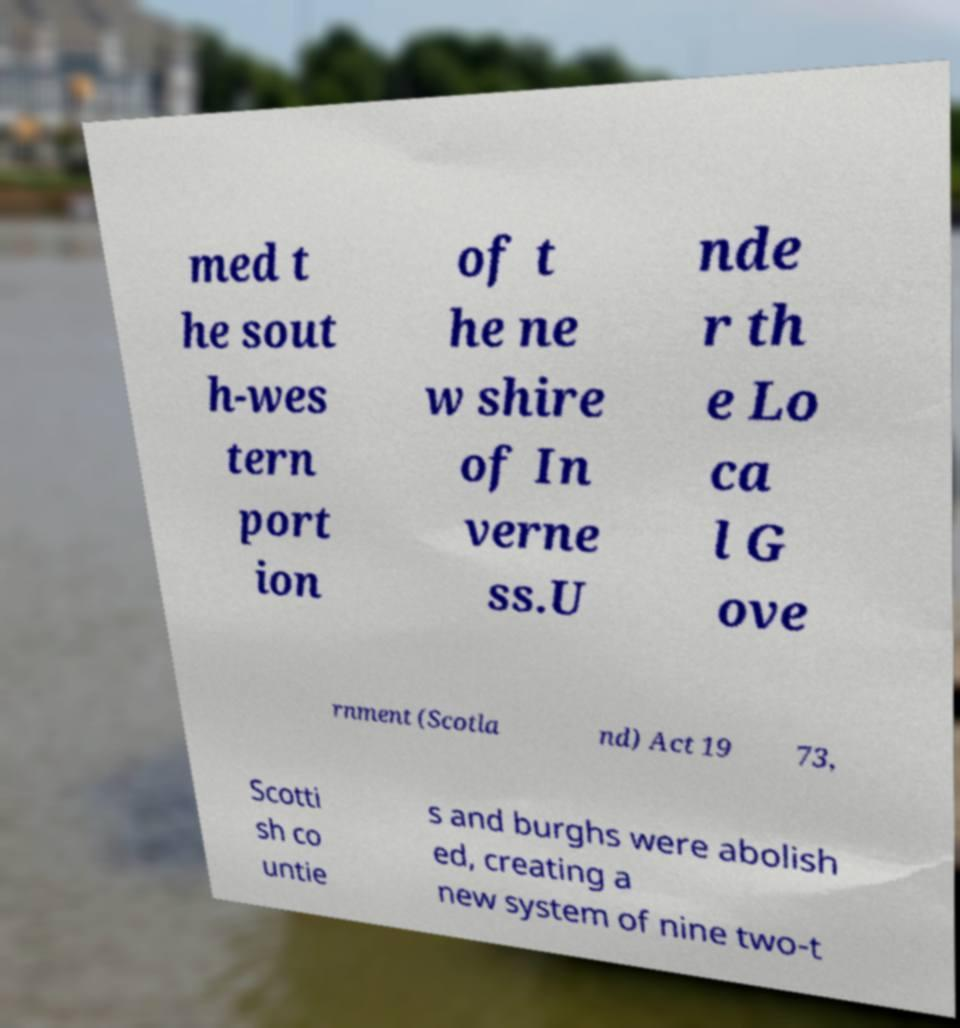What messages or text are displayed in this image? I need them in a readable, typed format. med t he sout h-wes tern port ion of t he ne w shire of In verne ss.U nde r th e Lo ca l G ove rnment (Scotla nd) Act 19 73, Scotti sh co untie s and burghs were abolish ed, creating a new system of nine two-t 